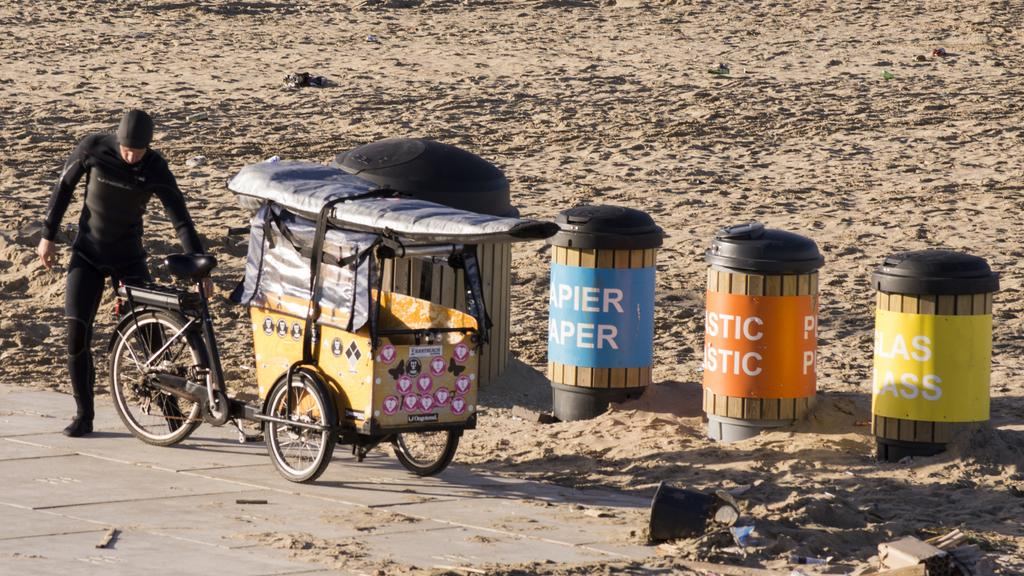Who or what is in the image? There is a person in the image. What is the person wearing? The person is wearing a black dress. Where is the person standing? The person is standing on the ground. What else can be seen on the ground? There are different kinds of boxes present on the ground. What type of toy is the person playing with in the image? There is no toy present in the image; the person is simply standing on the ground wearing a black dress. 